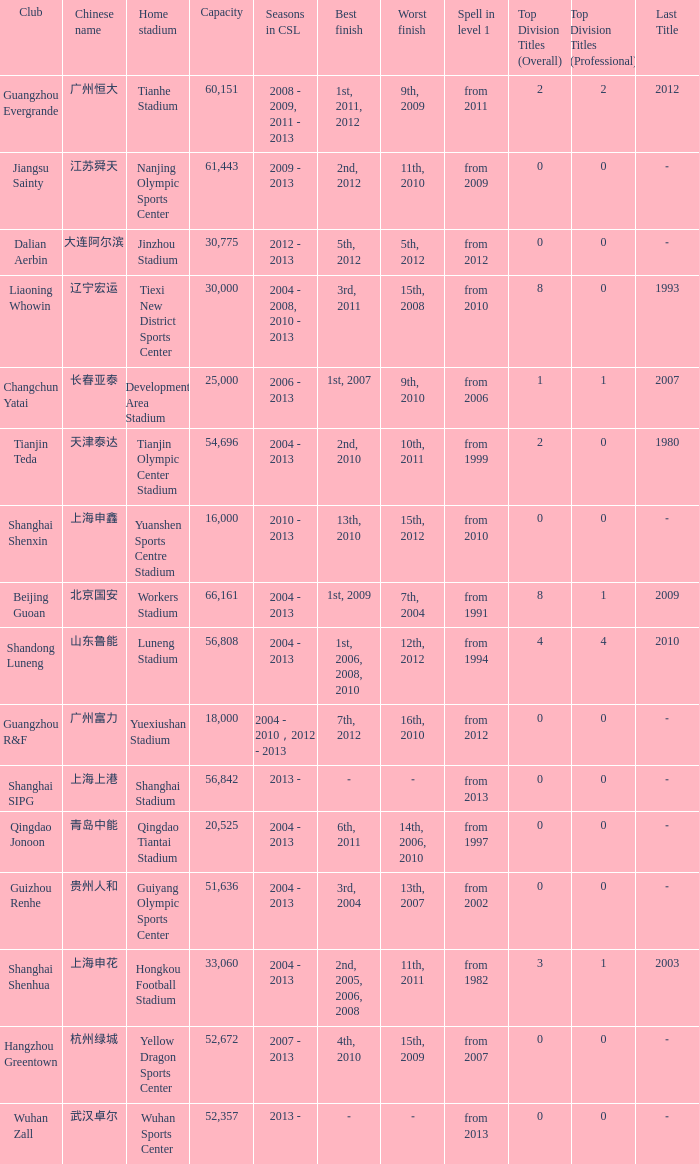What were the years for Seasons in CSL when they played in the Guiyang Olympic Sports Center and had Top Division Titles (Overall) of 0? 2004 - 2013. 